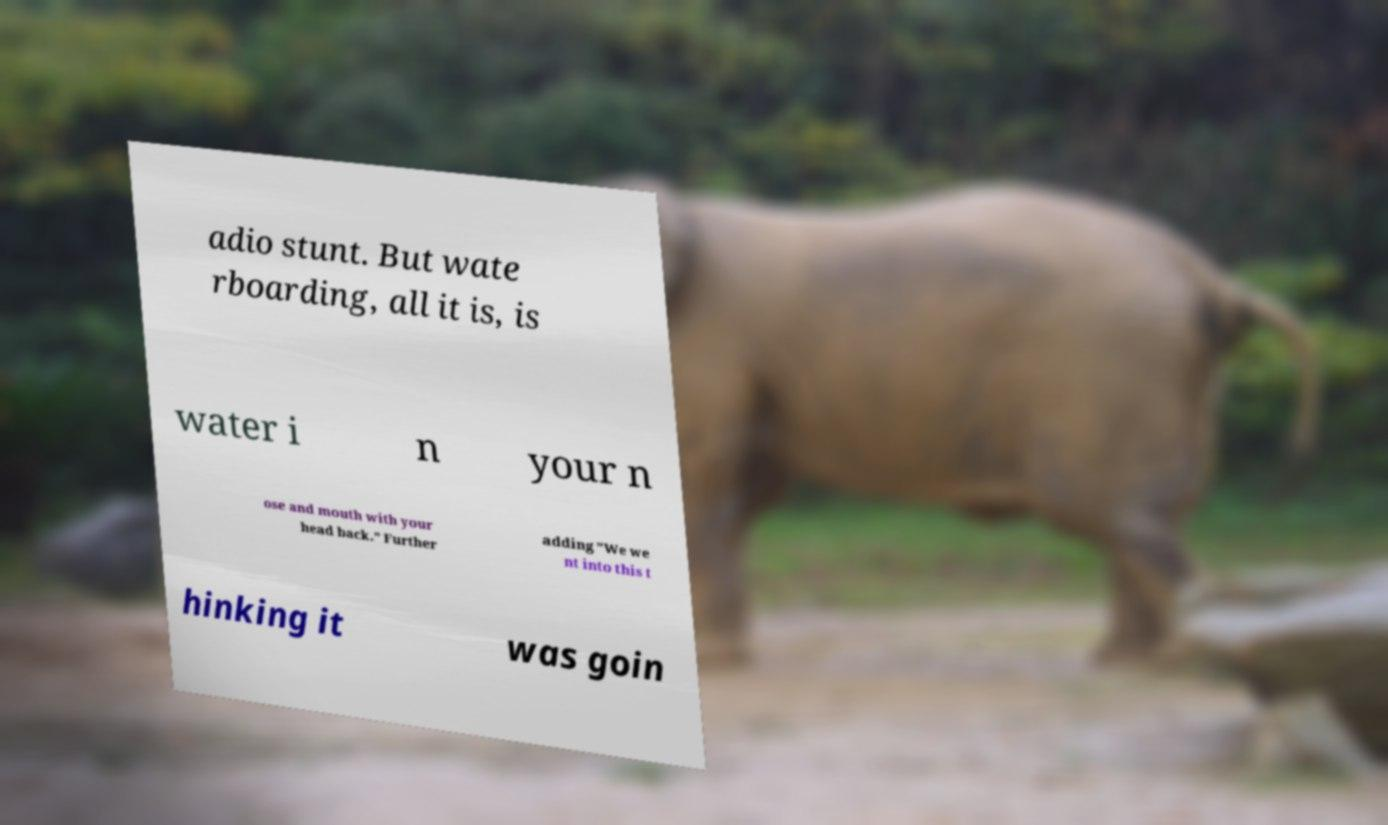Can you read and provide the text displayed in the image?This photo seems to have some interesting text. Can you extract and type it out for me? adio stunt. But wate rboarding, all it is, is water i n your n ose and mouth with your head back." Further adding "We we nt into this t hinking it was goin 